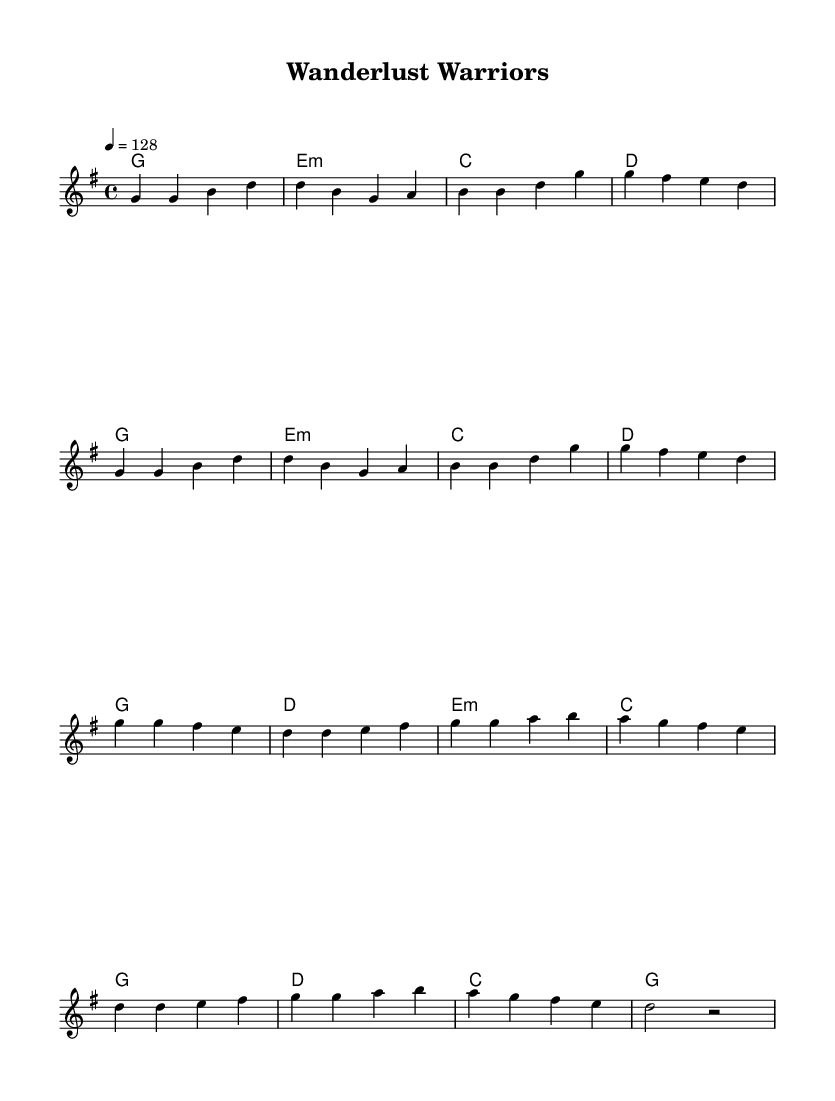What is the key signature of this music? The key signature is G major, which has one sharp (F#).
Answer: G major What is the time signature of this music? The time signature is 4/4, meaning there are four beats per measure.
Answer: 4/4 What is the tempo marking for this piece? The tempo marking is 128 beats per minute, indicating a moderately fast pace.
Answer: 128 How many measures are there in the verse section? The verse section consists of 8 measures, as indicated by the melody lines grouping.
Answer: 8 What is the first note of the chorus? The first note of the chorus is G, beginning the melodic line of that section.
Answer: G What type of musical form is used in this piece? The piece utilizes a verse-chorus form, which is common in K-Pop music.
Answer: Verse-chorus How is the harmony structured in the chorus section? The harmony consists of four chords in a loop: G, D, E minor, and C, aligning with the melody.
Answer: G, D, E minor, C 